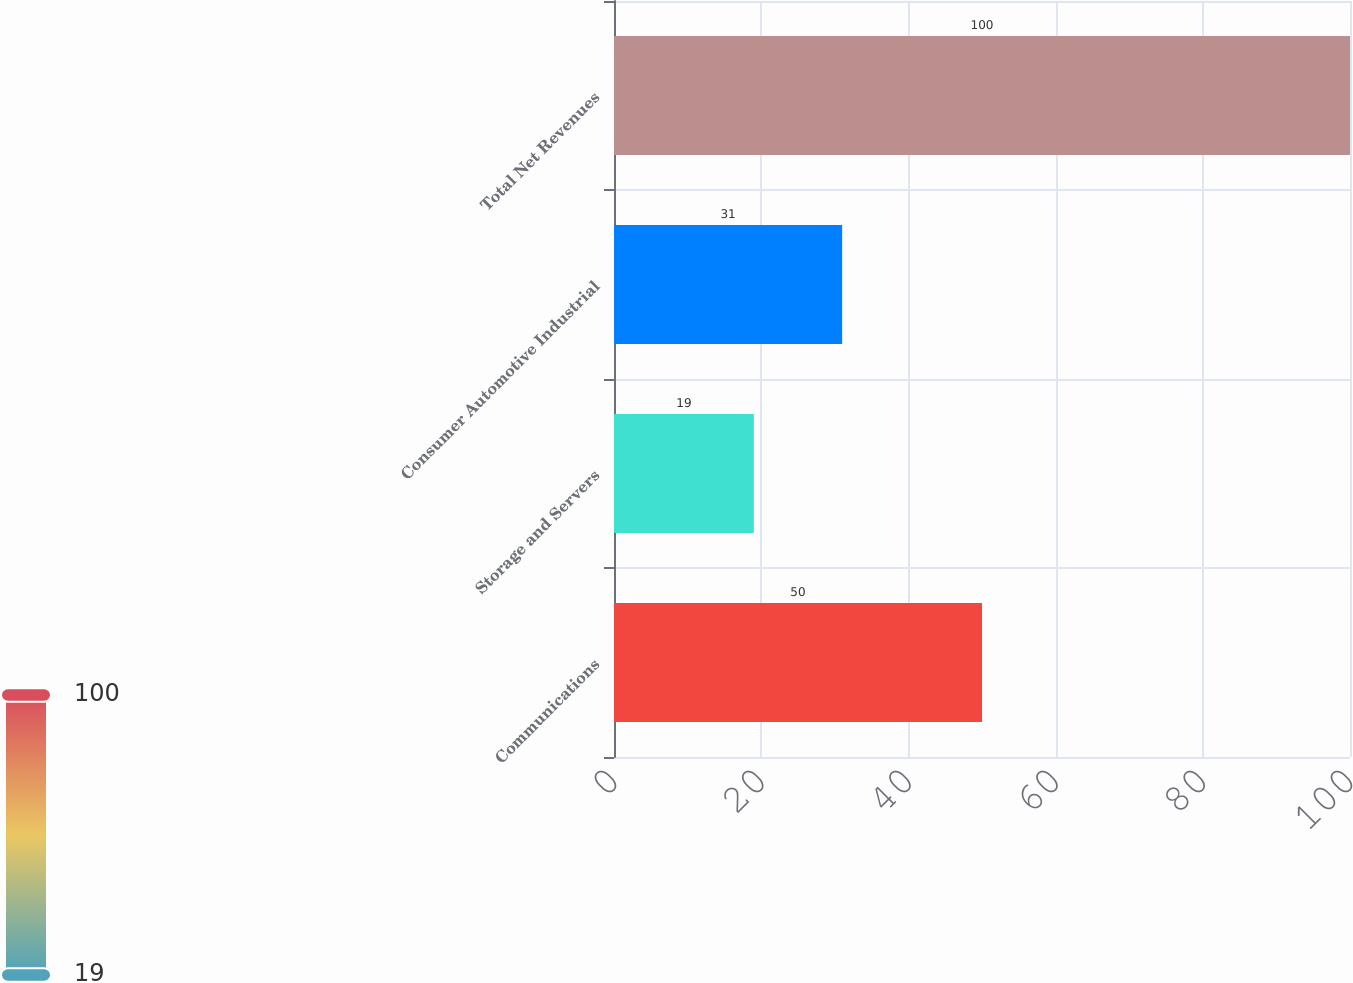Convert chart to OTSL. <chart><loc_0><loc_0><loc_500><loc_500><bar_chart><fcel>Communications<fcel>Storage and Servers<fcel>Consumer Automotive Industrial<fcel>Total Net Revenues<nl><fcel>50<fcel>19<fcel>31<fcel>100<nl></chart> 